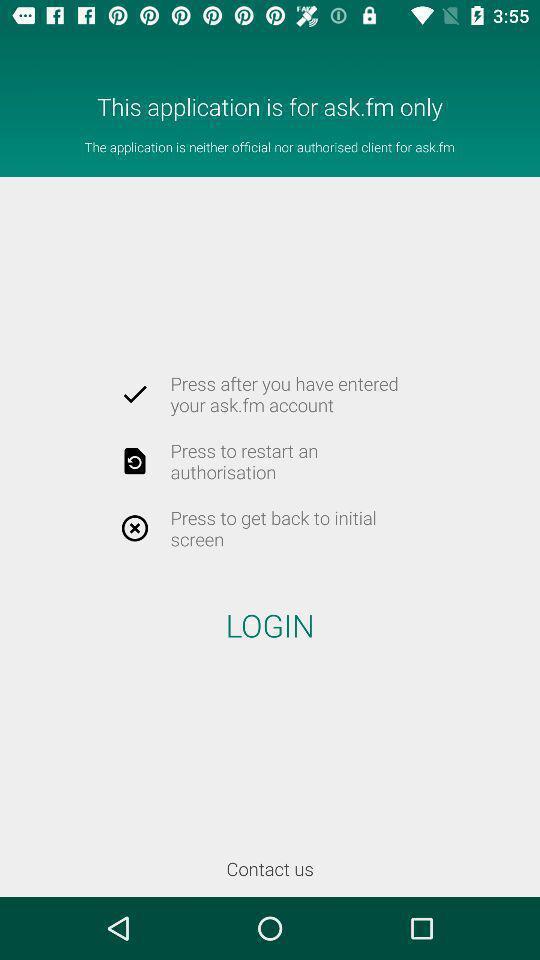Please provide a description for this image. Screen showing log in page. 